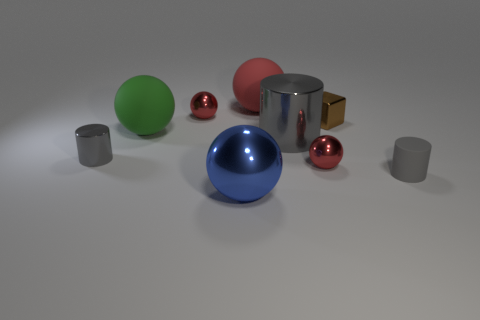What shape is the gray rubber object that is the same size as the brown shiny cube?
Provide a succinct answer. Cylinder. How many other objects are there of the same color as the big cylinder?
Give a very brief answer. 2. The rubber object right of the big red matte object is what color?
Ensure brevity in your answer.  Gray. How many other things are made of the same material as the big red sphere?
Keep it short and to the point. 2. Are there more green matte things in front of the block than small brown shiny things that are on the left side of the large shiny cylinder?
Ensure brevity in your answer.  Yes. There is a tiny brown metallic object; what number of large blue metal objects are on the right side of it?
Keep it short and to the point. 0. Is the material of the large green thing the same as the small cylinder that is right of the large gray metal cylinder?
Offer a terse response. Yes. Are there any other things that are the same shape as the tiny gray metallic object?
Provide a short and direct response. Yes. Is the large green thing made of the same material as the tiny cube?
Give a very brief answer. No. Is there a gray metal thing to the right of the tiny cylinder that is on the left side of the gray matte cylinder?
Provide a short and direct response. Yes. 